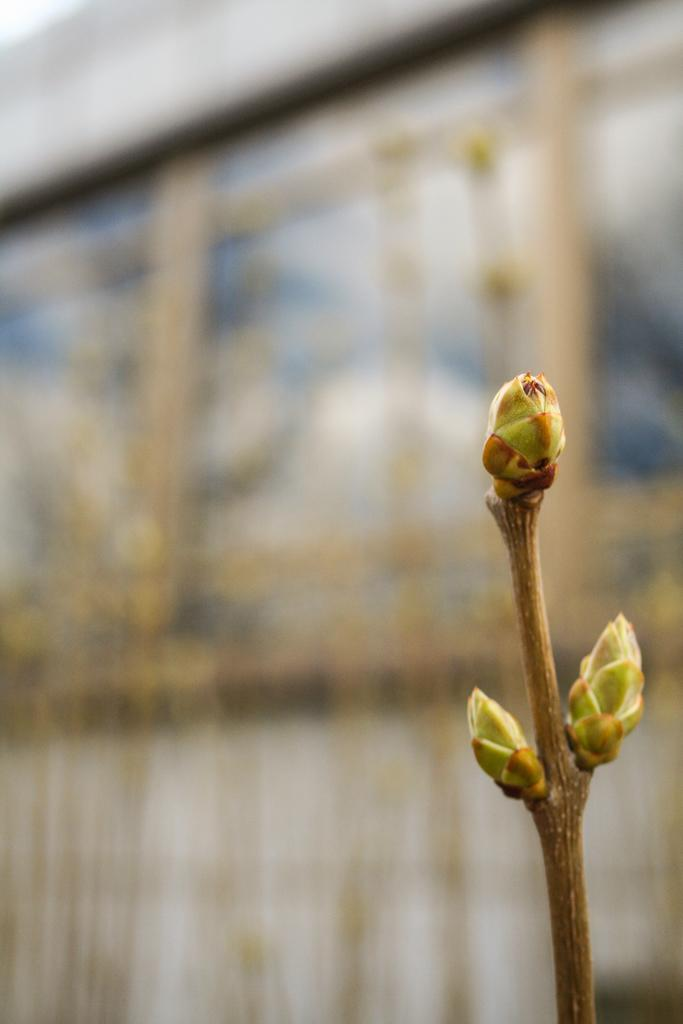What type of living organism is present in the image? There is a plant in the image. What is the color of the plant? The plant is brown in color. Are there any signs of growth or life on the plant? Yes, there are green buds on the plant. What can be seen in the background of the image? There is a building and the sky visible in the background of the image. What type of rose can be seen growing on the steps in the image? There is no rose or steps present in the image; it features a brown plant with green buds and a background with a building and the sky. 